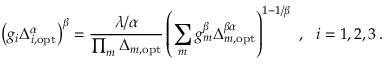<formula> <loc_0><loc_0><loc_500><loc_500>\left ( g _ { i } \Delta _ { i , o p t } ^ { \alpha } \right ) ^ { \beta } = \frac { \lambda / \alpha } { \prod _ { m } \Delta _ { m , o p t } } \left ( \sum _ { m } g _ { m } ^ { \beta } \Delta _ { m , o p t } ^ { \beta \alpha } \right ) ^ { 1 - 1 / \beta } \ , \ \ i = 1 , 2 , 3 \, .</formula> 